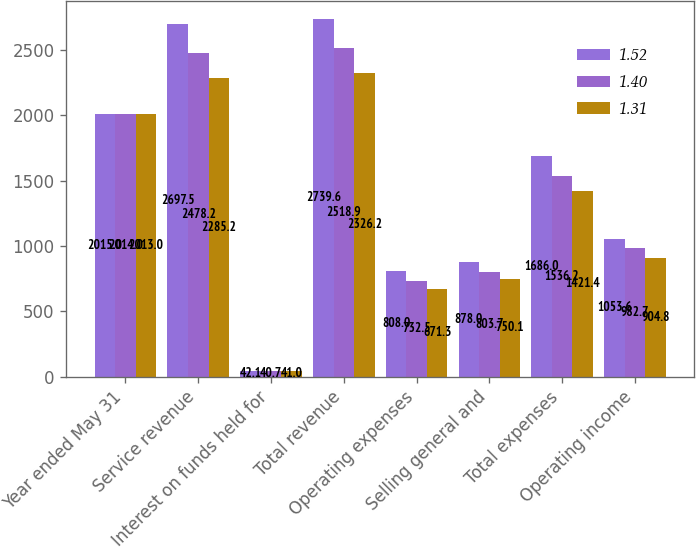<chart> <loc_0><loc_0><loc_500><loc_500><stacked_bar_chart><ecel><fcel>Year ended May 31<fcel>Service revenue<fcel>Interest on funds held for<fcel>Total revenue<fcel>Operating expenses<fcel>Selling general and<fcel>Total expenses<fcel>Operating income<nl><fcel>1.52<fcel>2015<fcel>2697.5<fcel>42.1<fcel>2739.6<fcel>808<fcel>878<fcel>1686<fcel>1053.6<nl><fcel>1.4<fcel>2014<fcel>2478.2<fcel>40.7<fcel>2518.9<fcel>732.5<fcel>803.7<fcel>1536.2<fcel>982.7<nl><fcel>1.31<fcel>2013<fcel>2285.2<fcel>41<fcel>2326.2<fcel>671.3<fcel>750.1<fcel>1421.4<fcel>904.8<nl></chart> 